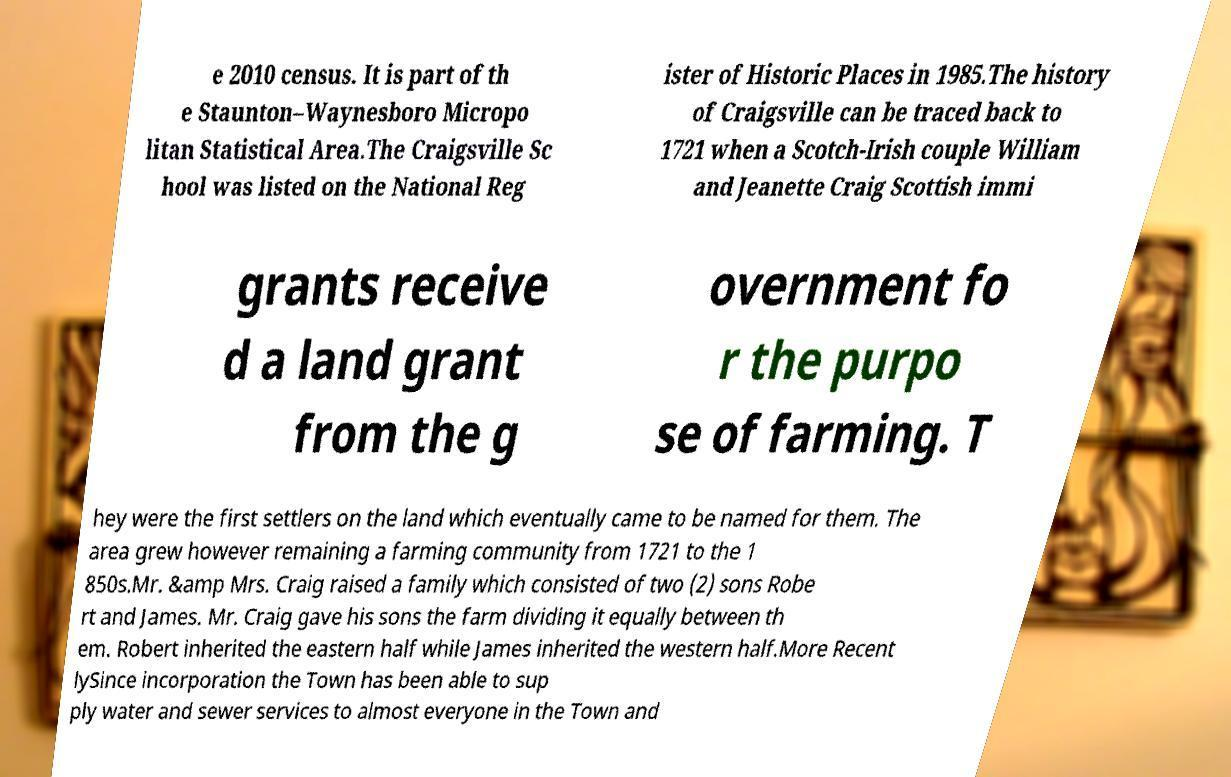I need the written content from this picture converted into text. Can you do that? e 2010 census. It is part of th e Staunton–Waynesboro Micropo litan Statistical Area.The Craigsville Sc hool was listed on the National Reg ister of Historic Places in 1985.The history of Craigsville can be traced back to 1721 when a Scotch-Irish couple William and Jeanette Craig Scottish immi grants receive d a land grant from the g overnment fo r the purpo se of farming. T hey were the first settlers on the land which eventually came to be named for them. The area grew however remaining a farming community from 1721 to the 1 850s.Mr. &amp Mrs. Craig raised a family which consisted of two (2) sons Robe rt and James. Mr. Craig gave his sons the farm dividing it equally between th em. Robert inherited the eastern half while James inherited the western half.More Recent lySince incorporation the Town has been able to sup ply water and sewer services to almost everyone in the Town and 